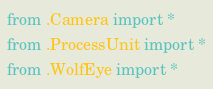Convert code to text. <code><loc_0><loc_0><loc_500><loc_500><_Python_>from .Camera import *
from .ProcessUnit import *
from .WolfEye import *
</code> 